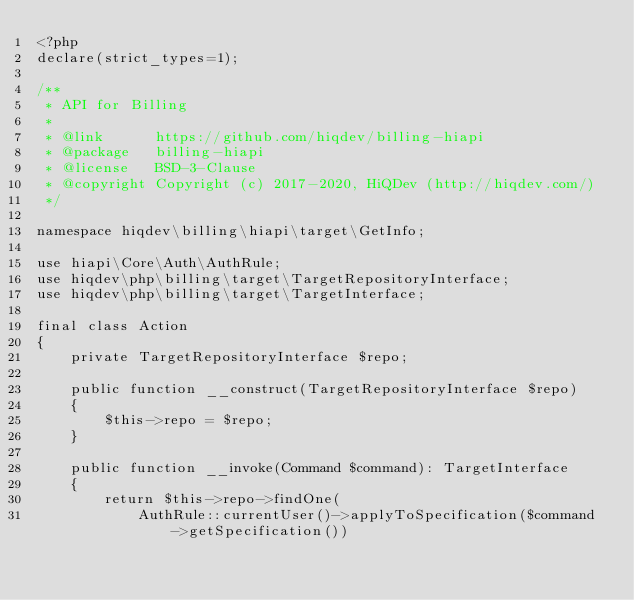Convert code to text. <code><loc_0><loc_0><loc_500><loc_500><_PHP_><?php
declare(strict_types=1);

/**
 * API for Billing
 *
 * @link      https://github.com/hiqdev/billing-hiapi
 * @package   billing-hiapi
 * @license   BSD-3-Clause
 * @copyright Copyright (c) 2017-2020, HiQDev (http://hiqdev.com/)
 */

namespace hiqdev\billing\hiapi\target\GetInfo;

use hiapi\Core\Auth\AuthRule;
use hiqdev\php\billing\target\TargetRepositoryInterface;
use hiqdev\php\billing\target\TargetInterface;

final class Action
{
    private TargetRepositoryInterface $repo;

    public function __construct(TargetRepositoryInterface $repo)
    {
        $this->repo = $repo;
    }

    public function __invoke(Command $command): TargetInterface
    {
        return $this->repo->findOne(
            AuthRule::currentUser()->applyToSpecification($command->getSpecification())</code> 